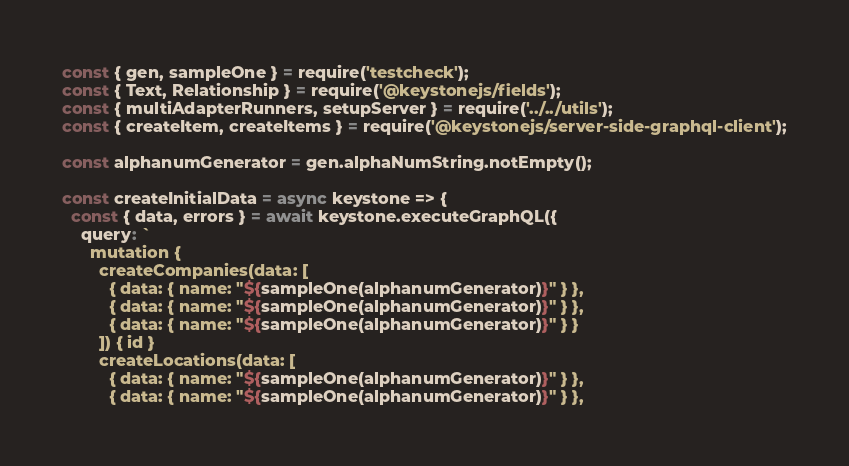<code> <loc_0><loc_0><loc_500><loc_500><_JavaScript_>const { gen, sampleOne } = require('testcheck');
const { Text, Relationship } = require('@keystonejs/fields');
const { multiAdapterRunners, setupServer } = require('../../utils');
const { createItem, createItems } = require('@keystonejs/server-side-graphql-client');

const alphanumGenerator = gen.alphaNumString.notEmpty();

const createInitialData = async keystone => {
  const { data, errors } = await keystone.executeGraphQL({
    query: `
      mutation {
        createCompanies(data: [
          { data: { name: "${sampleOne(alphanumGenerator)}" } },
          { data: { name: "${sampleOne(alphanumGenerator)}" } },
          { data: { name: "${sampleOne(alphanumGenerator)}" } }
        ]) { id }
        createLocations(data: [
          { data: { name: "${sampleOne(alphanumGenerator)}" } },
          { data: { name: "${sampleOne(alphanumGenerator)}" } },</code> 